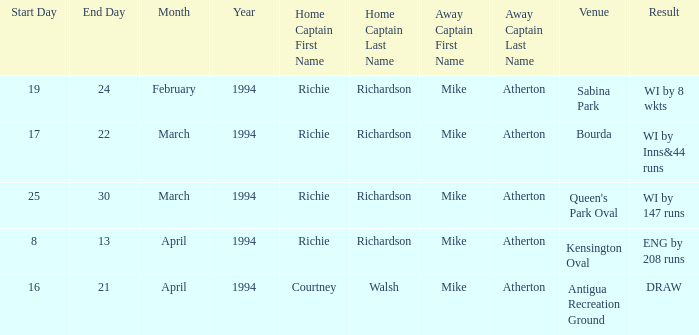Which Home Captain has Venue of Bourda? Richie Richardson. 